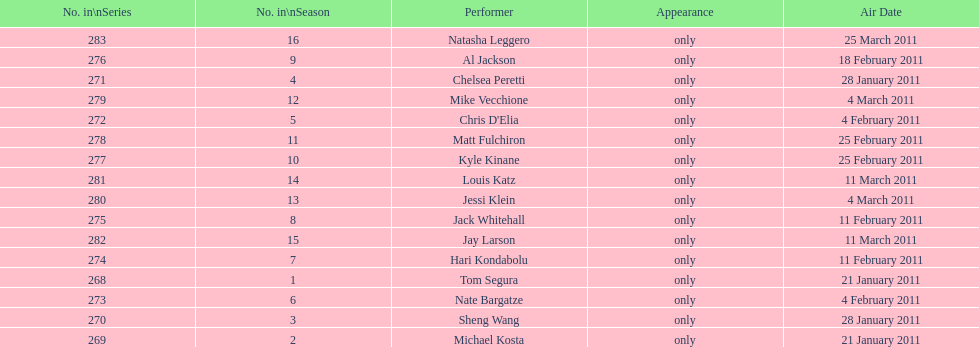What is the name of the last performer on this chart? Natasha Leggero. 